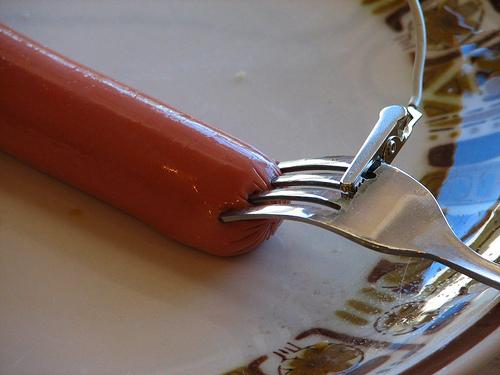What is in the hot dog?
Quick response, please. Fork. What is on the bottom tines of the fork?
Answer briefly. Alligator clip. Would a vegetarian eat this hot dog?
Write a very short answer. No. 